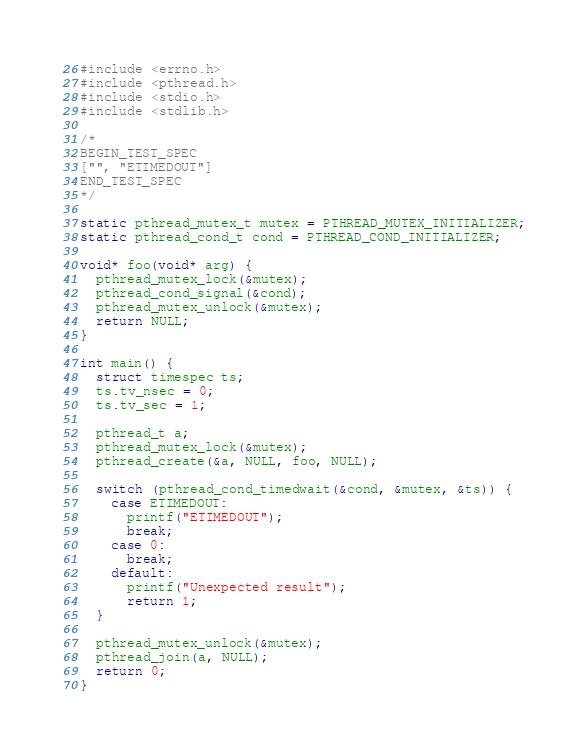<code> <loc_0><loc_0><loc_500><loc_500><_C_>#include <errno.h>
#include <pthread.h>
#include <stdio.h>
#include <stdlib.h>

/*
BEGIN_TEST_SPEC
["", "ETIMEDOUT"]
END_TEST_SPEC
*/

static pthread_mutex_t mutex = PTHREAD_MUTEX_INITIALIZER;
static pthread_cond_t cond = PTHREAD_COND_INITIALIZER;

void* foo(void* arg) {
  pthread_mutex_lock(&mutex);
  pthread_cond_signal(&cond);
  pthread_mutex_unlock(&mutex);
  return NULL;
}

int main() {
  struct timespec ts;
  ts.tv_nsec = 0;
  ts.tv_sec = 1;

  pthread_t a;
  pthread_mutex_lock(&mutex);
  pthread_create(&a, NULL, foo, NULL);

  switch (pthread_cond_timedwait(&cond, &mutex, &ts)) {
    case ETIMEDOUT:
      printf("ETIMEDOUT");
      break;
    case 0:
      break;
    default:
      printf("Unexpected result");
      return 1;
  }

  pthread_mutex_unlock(&mutex);
  pthread_join(a, NULL);
  return 0;
}</code> 